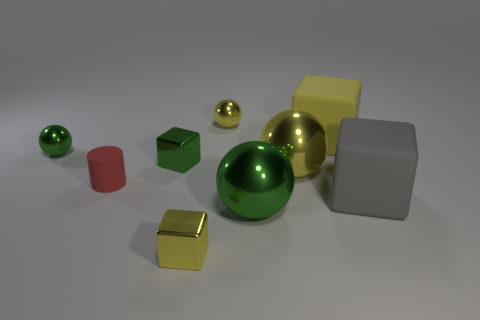Subtract all large gray matte blocks. How many blocks are left? 3 Subtract 4 balls. How many balls are left? 0 Subtract all blue cubes. How many green balls are left? 2 Subtract all yellow balls. How many balls are left? 2 Subtract all cubes. How many objects are left? 5 Subtract all small green objects. Subtract all tiny yellow balls. How many objects are left? 6 Add 3 green metal things. How many green metal things are left? 6 Add 3 yellow matte things. How many yellow matte things exist? 4 Subtract 0 purple cylinders. How many objects are left? 9 Subtract all cyan cylinders. Subtract all green balls. How many cylinders are left? 1 